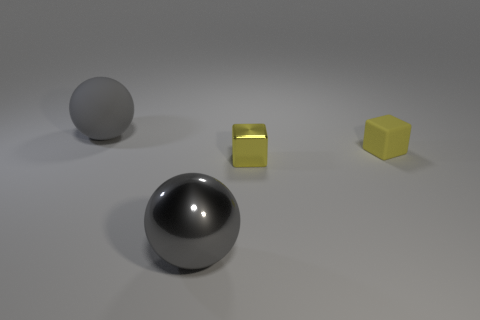Subtract all yellow spheres. Subtract all green cubes. How many spheres are left? 2 Subtract all brown cubes. How many green spheres are left? 0 Subtract all small matte things. Subtract all gray rubber objects. How many objects are left? 2 Add 4 matte balls. How many matte balls are left? 5 Add 4 rubber spheres. How many rubber spheres exist? 5 Add 2 large brown shiny cylinders. How many objects exist? 6 Subtract 0 brown cubes. How many objects are left? 4 Subtract 2 balls. How many balls are left? 0 